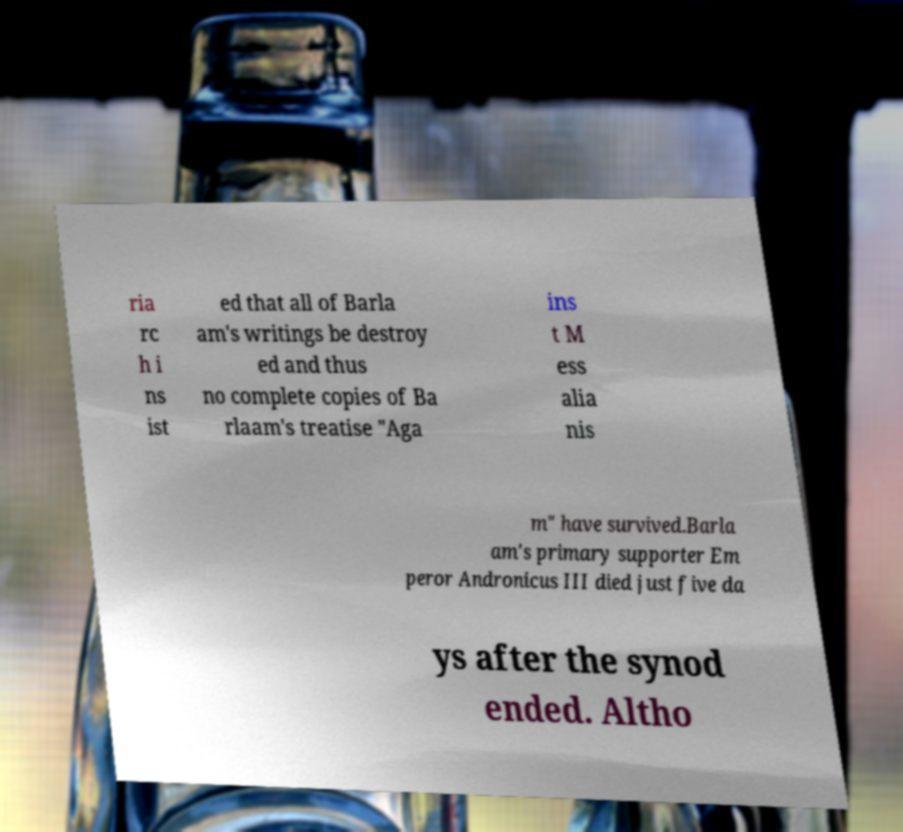What messages or text are displayed in this image? I need them in a readable, typed format. ria rc h i ns ist ed that all of Barla am's writings be destroy ed and thus no complete copies of Ba rlaam's treatise "Aga ins t M ess alia nis m" have survived.Barla am's primary supporter Em peror Andronicus III died just five da ys after the synod ended. Altho 